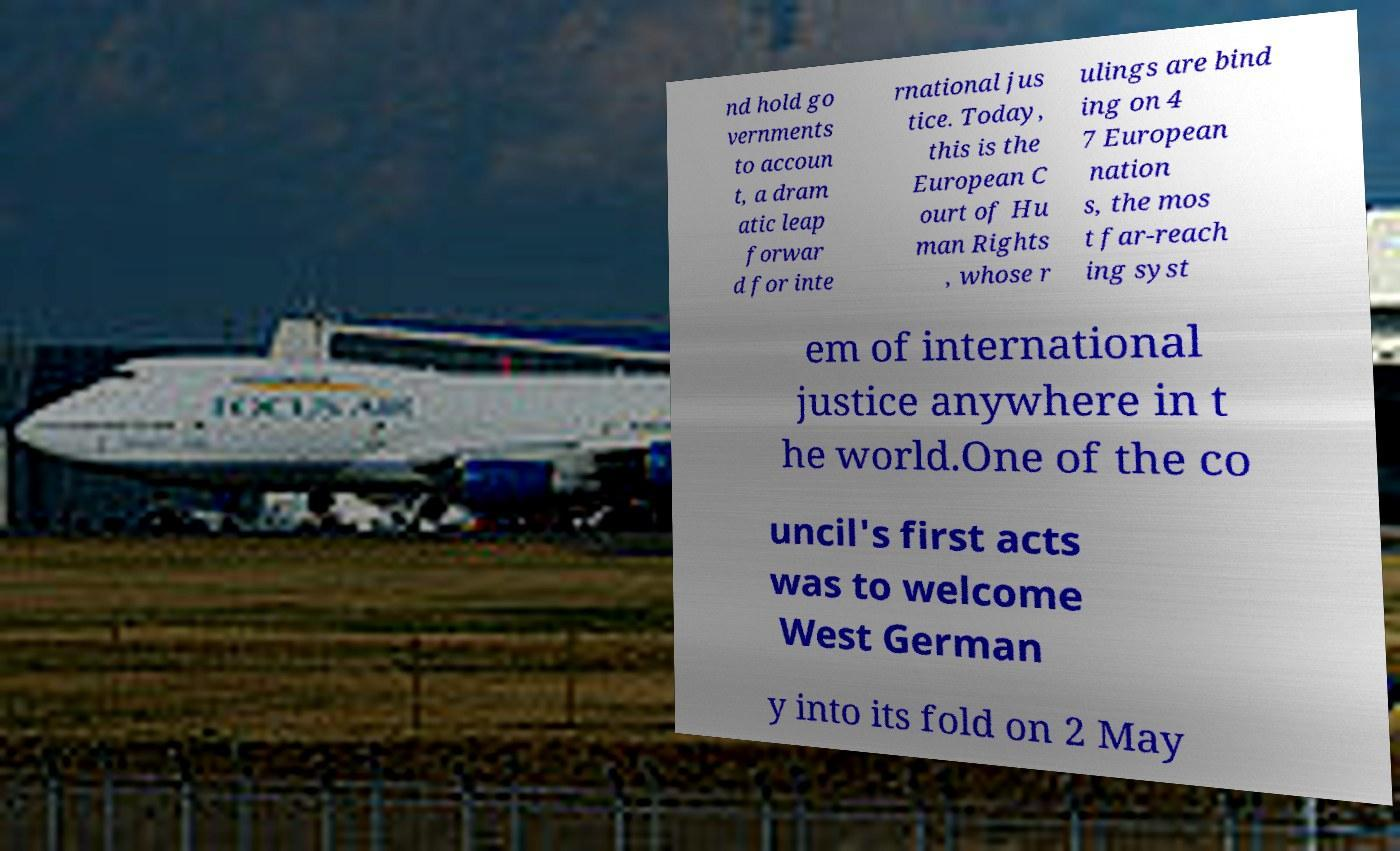Can you read and provide the text displayed in the image?This photo seems to have some interesting text. Can you extract and type it out for me? nd hold go vernments to accoun t, a dram atic leap forwar d for inte rnational jus tice. Today, this is the European C ourt of Hu man Rights , whose r ulings are bind ing on 4 7 European nation s, the mos t far-reach ing syst em of international justice anywhere in t he world.One of the co uncil's first acts was to welcome West German y into its fold on 2 May 